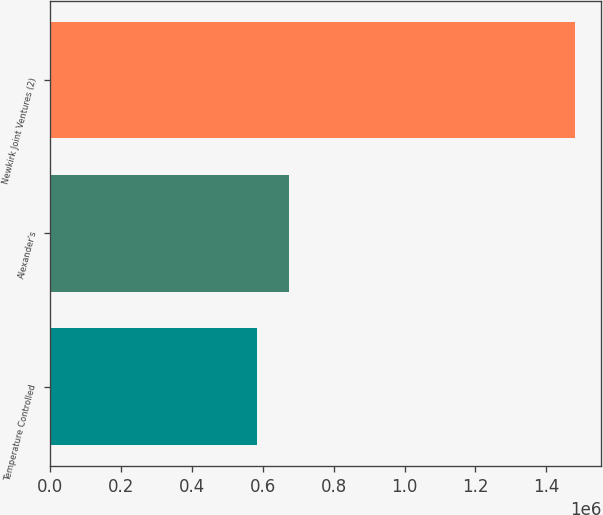Convert chart. <chart><loc_0><loc_0><loc_500><loc_500><bar_chart><fcel>Temperature Controlled<fcel>Alexander's<fcel>Newkirk Joint Ventures (2)<nl><fcel>584511<fcel>674162<fcel>1.48103e+06<nl></chart> 